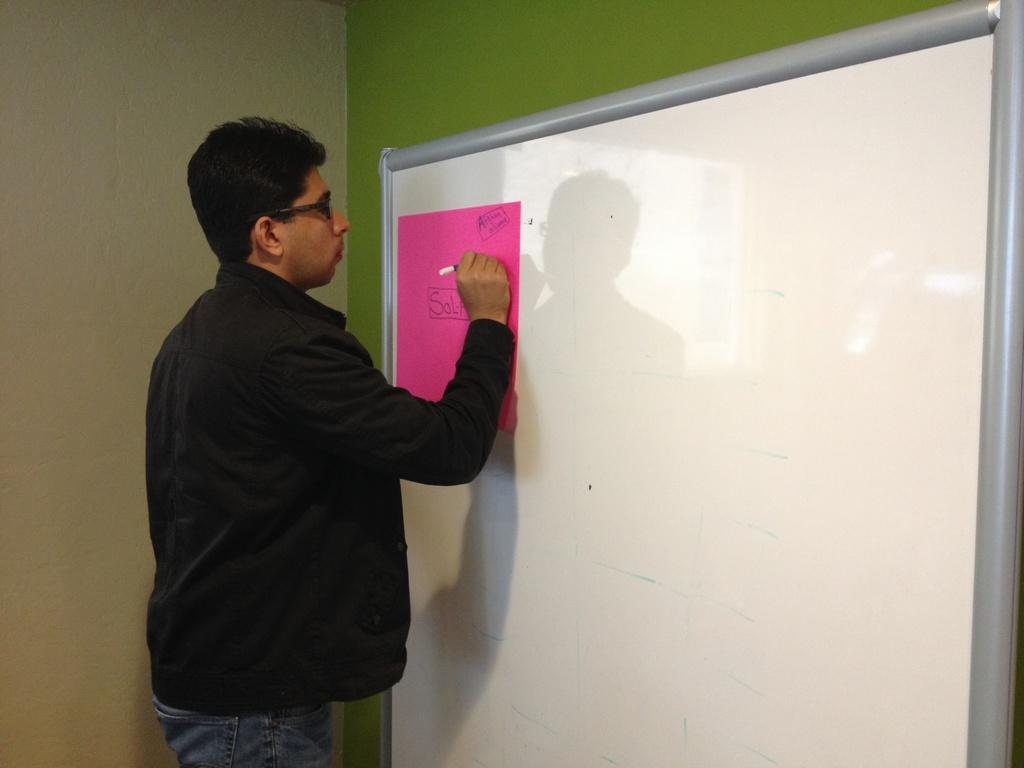What is the man in the image doing? The man is standing in the middle of the image and writing on a board. What is located behind the man in the image? There is a wall behind the man in the image. Where is the woman in the image? There is no woman present in the image. What type of tub is visible in the image? There is no tub present in the image. 